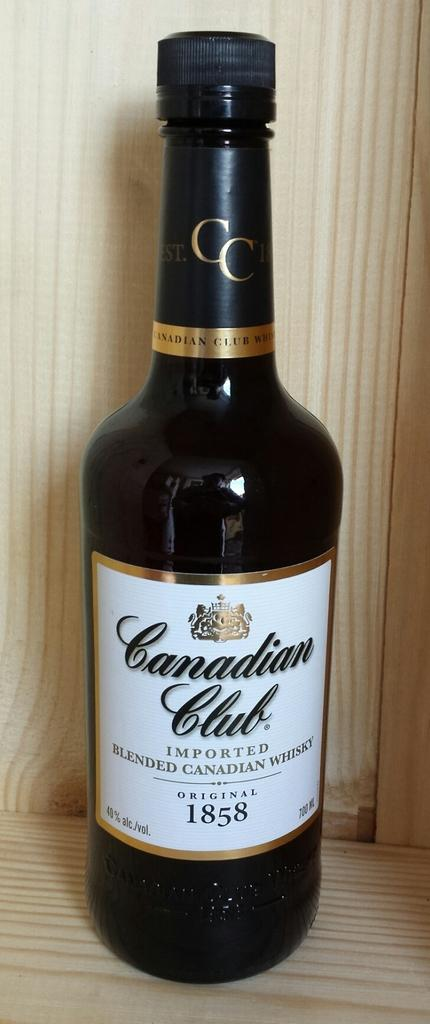<image>
Give a short and clear explanation of the subsequent image. A bottle has the year 1858 on the label. 